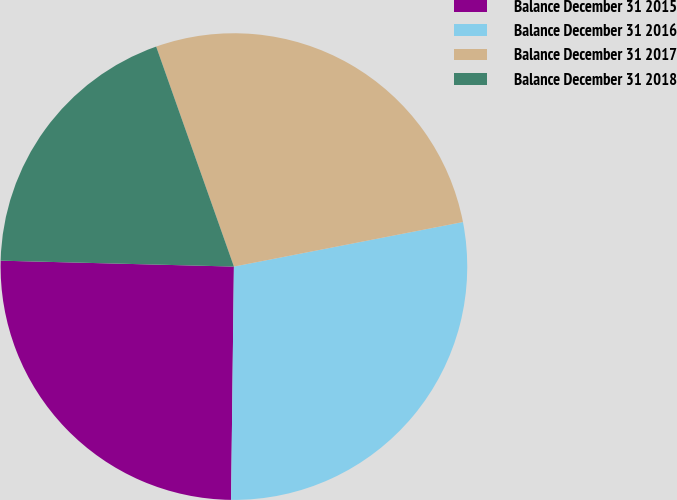Convert chart to OTSL. <chart><loc_0><loc_0><loc_500><loc_500><pie_chart><fcel>Balance December 31 2015<fcel>Balance December 31 2016<fcel>Balance December 31 2017<fcel>Balance December 31 2018<nl><fcel>25.21%<fcel>28.25%<fcel>27.35%<fcel>19.19%<nl></chart> 